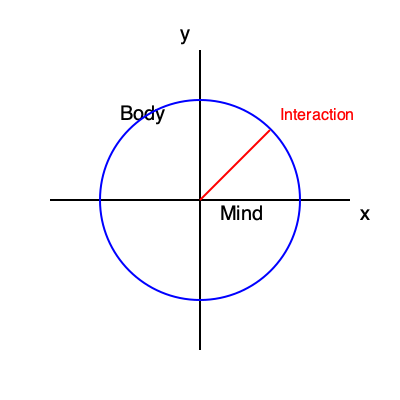How does the Cartesian coordinate system, as depicted in the image, serve as a metaphor for Descartes' mind-body dualism? Explain the significance of the origin (0,0) in this representation. 1. Cartesian Coordinate System:
   - The x-axis represents the physical world (res extensa)
   - The y-axis represents the mental world (res cogitans)

2. Mind-Body Dualism:
   - Descartes proposed that mind and body are distinct substances
   - The perpendicular axes illustrate their fundamental difference

3. Origin (0,0):
   - Represents the point of interaction between mind and body
   - Symbolizes the pineal gland in Descartes' theory

4. Circle:
   - Represents the unity of human experience
   - Shows how mind and body, though distinct, form a complete being

5. Interaction Line:
   - Illustrates the causal interaction between mind and body
   - Demonstrates that despite their separation, they can influence each other

6. Quadrants:
   - Each quadrant represents different aspects of human experience
   - Positive x, positive y: conscious physical experiences
   - Negative x, positive y: purely mental experiences (e.g., abstract thought)
   - Positive x, negative y: unconscious physical processes
   - Negative x, negative y: subconscious mental processes

This representation helps visualize Descartes' concept of two distinct substances interacting at a single point, while maintaining their separate natures.
Answer: The origin (0,0) represents the pineal gland, the point of mind-body interaction in Descartes' dualism. 